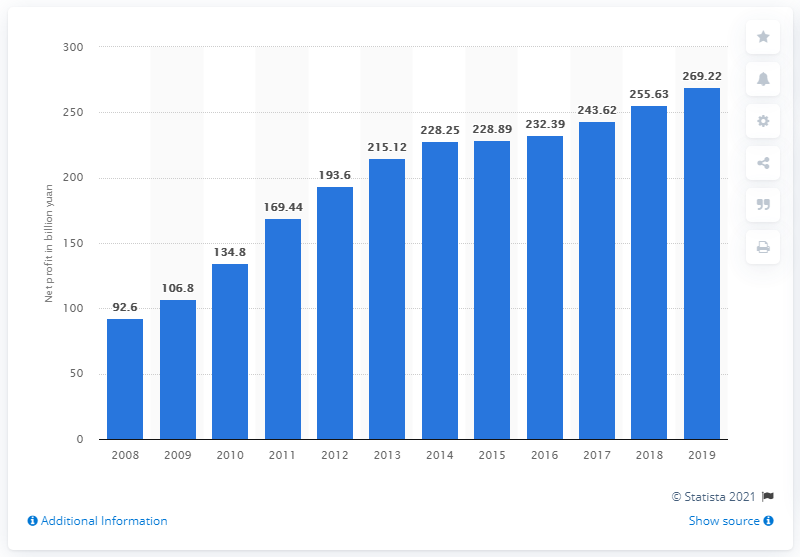Mention a couple of crucial points in this snapshot. In 2019, the net profit of China Construction Bank was 269.22 billion yuan. 